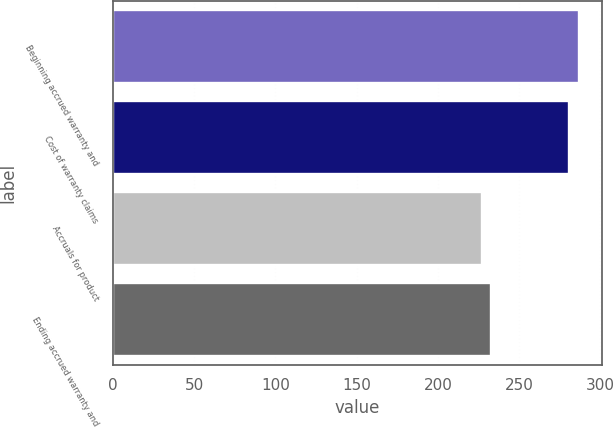Convert chart. <chart><loc_0><loc_0><loc_500><loc_500><bar_chart><fcel>Beginning accrued warranty and<fcel>Cost of warranty claims<fcel>Accruals for product<fcel>Ending accrued warranty and<nl><fcel>286.7<fcel>281<fcel>227<fcel>232.7<nl></chart> 